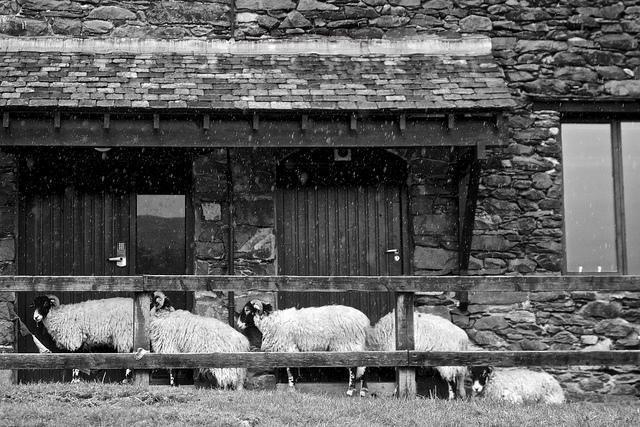How many sheep are in the picture?
Give a very brief answer. 5. 